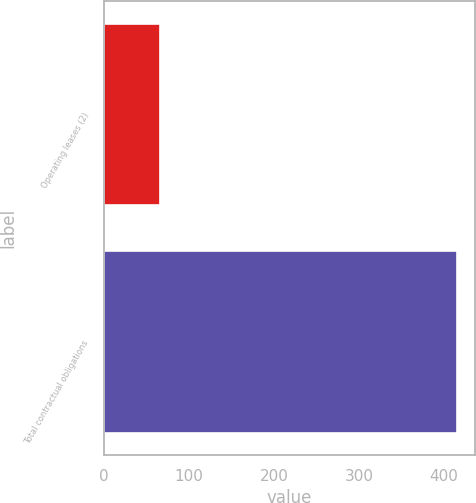Convert chart. <chart><loc_0><loc_0><loc_500><loc_500><bar_chart><fcel>Operating leases (2)<fcel>Total contractual obligations<nl><fcel>66<fcel>415<nl></chart> 